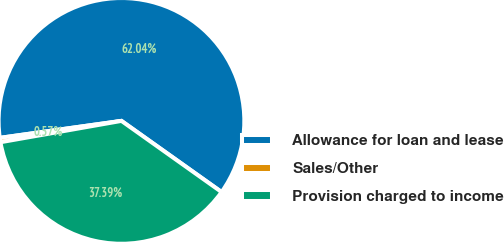<chart> <loc_0><loc_0><loc_500><loc_500><pie_chart><fcel>Allowance for loan and lease<fcel>Sales/Other<fcel>Provision charged to income<nl><fcel>62.04%<fcel>0.57%<fcel>37.39%<nl></chart> 